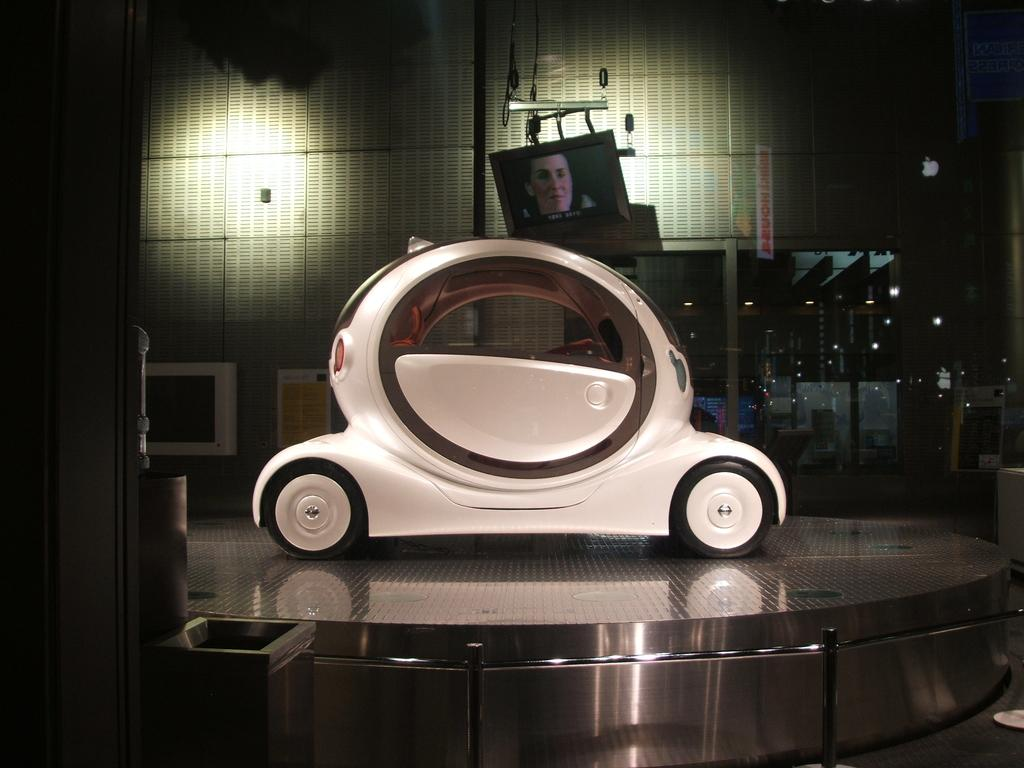What is the main subject in the center of the image? There is a car in the center of the image. Can you describe the color of the car? The car is white. What can be seen in the background of the image? There is a TV and a glass in the background of the image. What is happening on the TV? A woman is visible on the TV. What else can be seen in the background of the image? There are lights in the background of the image. What type of food is being prepared on the pencil in the image? There is no pencil or food preparation visible in the image. Which direction is the car facing in the image? The direction the car is facing cannot be determined from the image. 